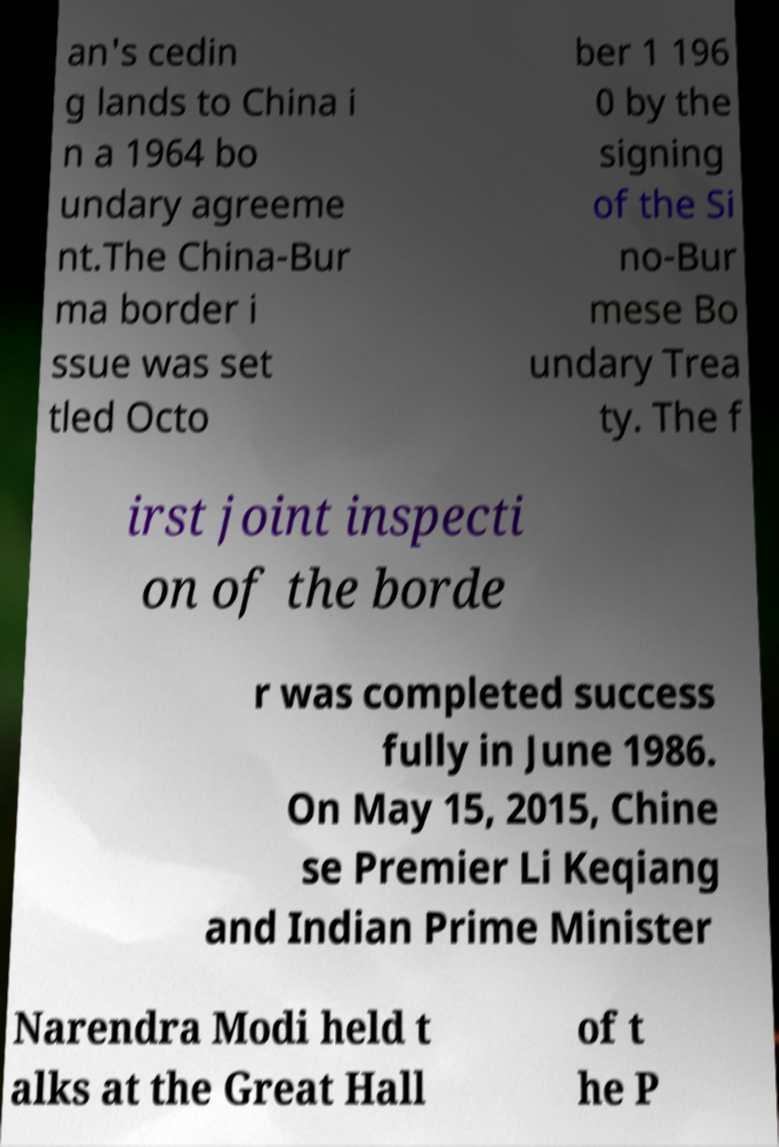Please read and relay the text visible in this image. What does it say? an's cedin g lands to China i n a 1964 bo undary agreeme nt.The China-Bur ma border i ssue was set tled Octo ber 1 196 0 by the signing of the Si no-Bur mese Bo undary Trea ty. The f irst joint inspecti on of the borde r was completed success fully in June 1986. On May 15, 2015, Chine se Premier Li Keqiang and Indian Prime Minister Narendra Modi held t alks at the Great Hall of t he P 